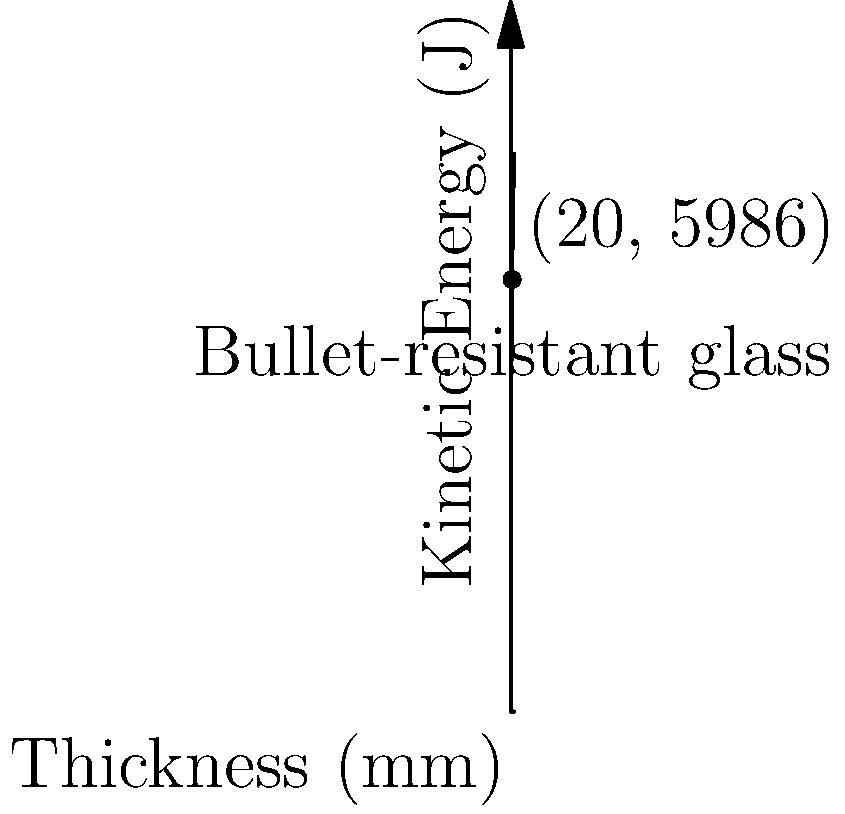A security checkpoint window requires bullet-resistant glass that can withstand a kinetic energy of 6000 J. Using the graph, which shows the relationship between glass thickness and the kinetic energy it can withstand, determine the minimum thickness of bullet-resistant glass needed. The relationship is given by the equation $E = 2000 \ln(t+1)$, where $E$ is the kinetic energy in joules and $t$ is the thickness in millimeters. To solve this problem, we need to follow these steps:

1) The given equation is $E = 2000 \ln(t+1)$, where $E$ is the kinetic energy and $t$ is the thickness.

2) We need to find $t$ when $E = 6000$ J.

3) Substituting the values:
   
   $6000 = 2000 \ln(t+1)$

4) Dividing both sides by 2000:
   
   $3 = \ln(t+1)$

5) To isolate $t$, we need to apply the exponential function to both sides:
   
   $e^3 = t+1$

6) Subtract 1 from both sides:
   
   $e^3 - 1 = t$

7) Calculate the value:
   
   $t = e^3 - 1 \approx 20.09$ mm

8) Rounding up to ensure safety, the minimum thickness needed is 21 mm.

9) We can verify this on the graph by locating the point where the curve intersects the 6000 J line, which is slightly above the 20 mm mark.
Answer: 21 mm 